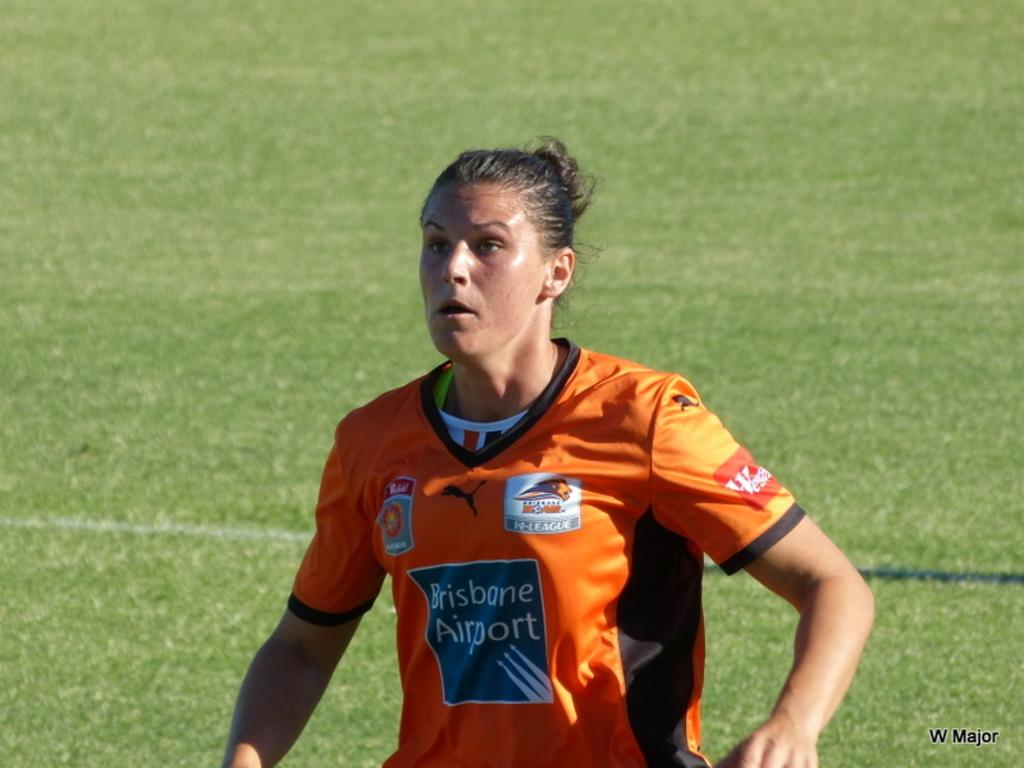<image>
Give a short and clear explanation of the subsequent image. A soccer player sponsored by the Brisbane Airport runs across the field. 